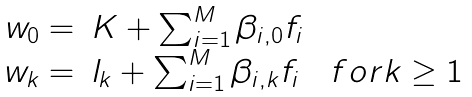<formula> <loc_0><loc_0><loc_500><loc_500>\begin{array} { r l } w _ { 0 } = & K + \sum _ { i = 1 } ^ { M } \beta _ { i , 0 } f _ { i } \\ w _ { k } = & l _ { k } + \sum _ { i = 1 } ^ { M } \beta _ { i , k } f _ { i } \quad f o r k \geq 1 \end{array}</formula> 